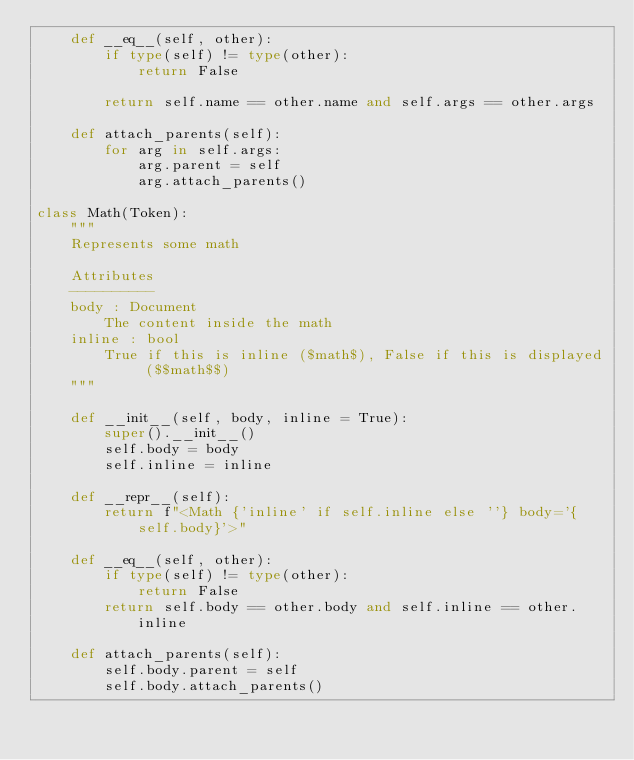Convert code to text. <code><loc_0><loc_0><loc_500><loc_500><_Python_>    def __eq__(self, other):
        if type(self) != type(other):
            return False

        return self.name == other.name and self.args == other.args

    def attach_parents(self):
        for arg in self.args:
            arg.parent = self
            arg.attach_parents()

class Math(Token):
    """
    Represents some math

    Attributes
    ----------
    body : Document
        The content inside the math
    inline : bool
        True if this is inline ($math$), False if this is displayed ($$math$$)
    """

    def __init__(self, body, inline = True):
        super().__init__()
        self.body = body
        self.inline = inline
    
    def __repr__(self):
        return f"<Math {'inline' if self.inline else ''} body='{self.body}'>"

    def __eq__(self, other):
        if type(self) != type(other):
            return False
        return self.body == other.body and self.inline == other.inline

    def attach_parents(self):
        self.body.parent = self
        self.body.attach_parents()</code> 